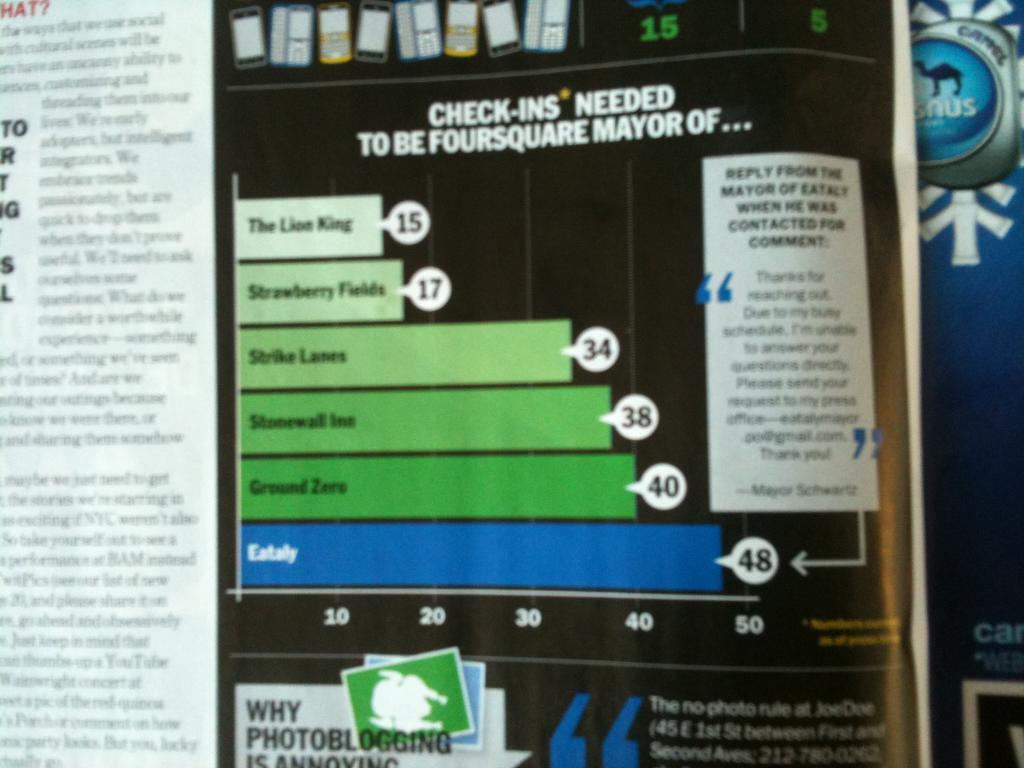Where is the 48 bar?
Make the answer very short. Eataly. How many check-ins to be the mayor of the lion king?
Your answer should be compact. 15. 